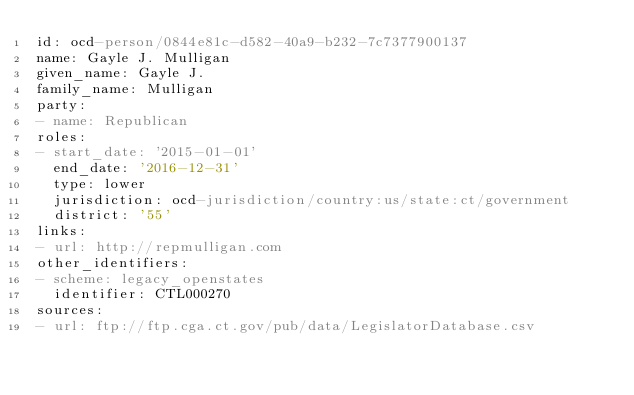<code> <loc_0><loc_0><loc_500><loc_500><_YAML_>id: ocd-person/0844e81c-d582-40a9-b232-7c7377900137
name: Gayle J. Mulligan
given_name: Gayle J.
family_name: Mulligan
party:
- name: Republican
roles:
- start_date: '2015-01-01'
  end_date: '2016-12-31'
  type: lower
  jurisdiction: ocd-jurisdiction/country:us/state:ct/government
  district: '55'
links:
- url: http://repmulligan.com
other_identifiers:
- scheme: legacy_openstates
  identifier: CTL000270
sources:
- url: ftp://ftp.cga.ct.gov/pub/data/LegislatorDatabase.csv
</code> 